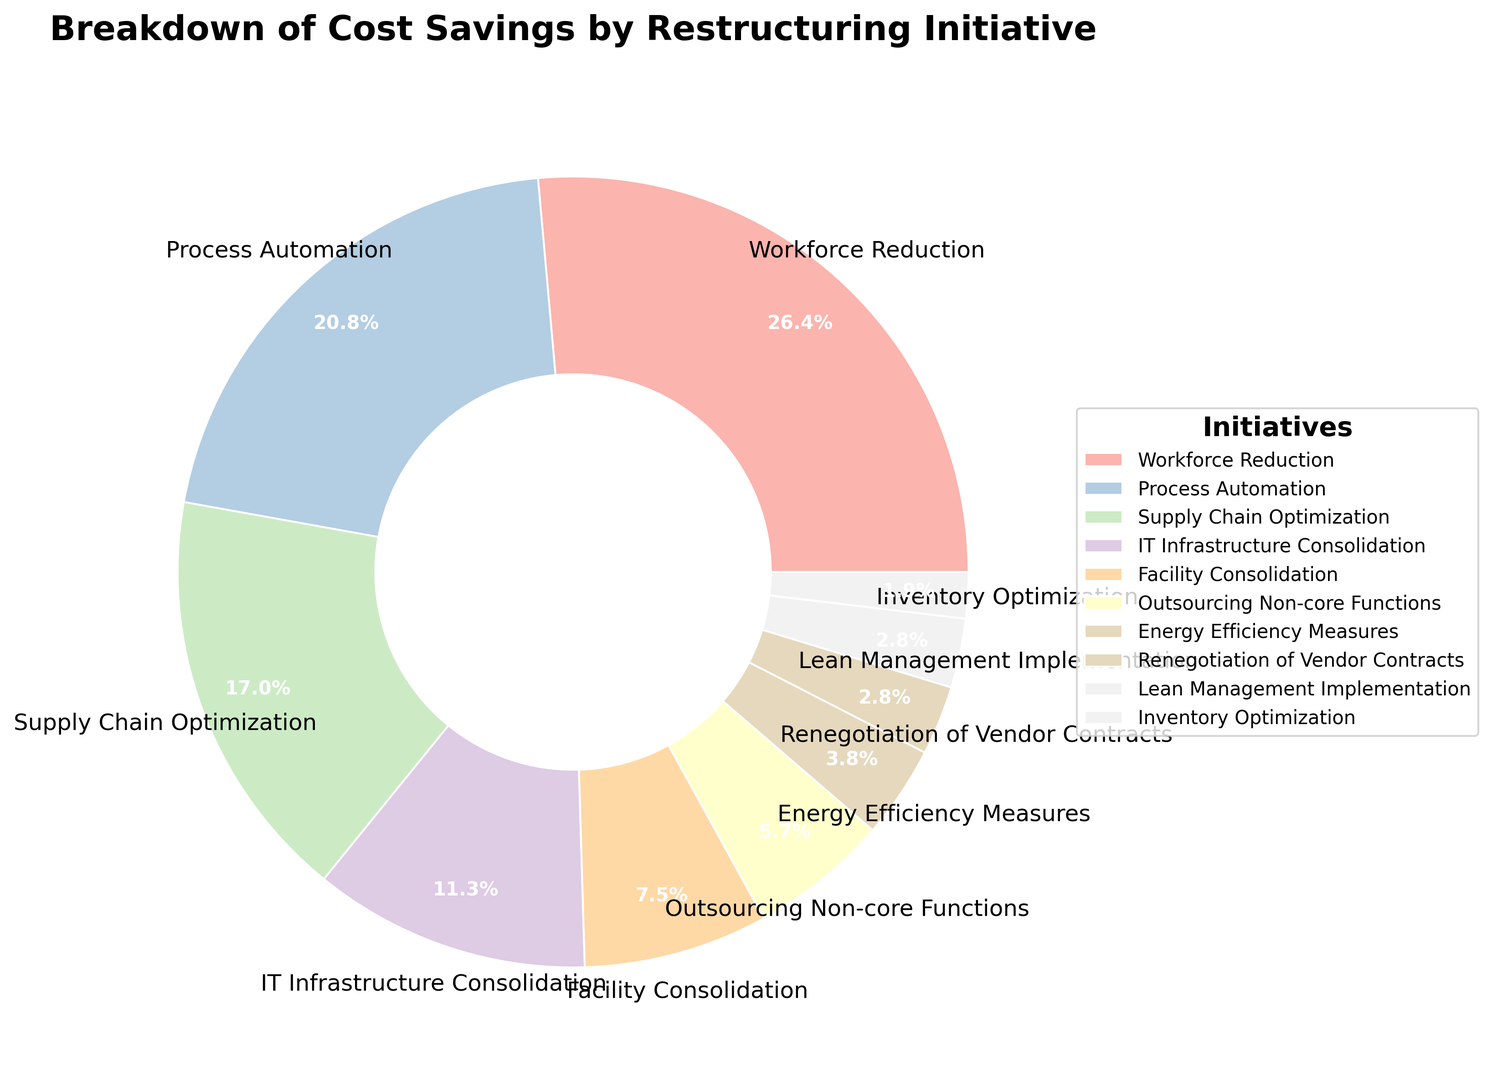What's the most significant cost-saving initiative represented in the chart? The initiative taking up the largest portion of the ring chart is 'Workforce Reduction', which is illustrated by a segment labeled with the highest percentage.
Answer: Workforce Reduction Which two initiatives together contribute to 40% of the cost savings? Initiatives 'Process Automation' and 'Supply Chain Optimization' together contribute 22% + 18% = 40%, as labeled on the chart.
Answer: Process Automation and Supply Chain Optimization Among 'Facility Consolidation', 'Energy Efficiency Measures', and 'Renegotiation of Vendor Contracts', which one contributes the least to cost savings? 'Renegotiation of Vendor Contracts' has the smallest segment among the three, making up only 3% of the ring chart.
Answer: Renegotiation of Vendor Contracts How much larger is the contribution of 'Workforce Reduction' compared to 'IT Infrastructure Consolidation'? The savings from 'Workforce Reduction' is 28%, and from 'IT Infrastructure Consolidation' is 12%. The difference is 28% - 12% = 16%.
Answer: 16% Which initiative represented in a pastel green color contributes to cost savings, and what is its percentage? On the color-coded ring chart, the initiative 'Supply Chain Optimization' is shown in a pastel green section, contributing 18% to the cost savings.
Answer: Supply Chain Optimization, 18% What is the total percentage of cost savings contributed by initiatives with less than 10% each? Adding the percentages of 'Outsourcing Non-core Functions' (6%), 'Energy Efficiency Measures' (4%), 'Renegotiation of Vendor Contracts' (3%), 'Lean Management Implementation' (3%), and 'Inventory Optimization' (2%) gives a total: 6% + 4% + 3% + 3% + 2% = 18%.
Answer: 18% Which initiatives have the exact same contribution percentage and what is that percentage? 'Renegotiation of Vendor Contracts' and 'Lean Management Implementation' both contribute 3% to the cost savings, as seen from identical-sized sections on the chart.
Answer: Renegotiation of Vendor Contracts and Lean Management Implementation, 3% What is the average percentage contribution of 'IT Infrastructure Consolidation', 'Facility Consolidation', and 'Outsourcing Non-core Functions'? Sum the contributions of 'IT Infrastructure Consolidation' (12%), 'Facility Consolidation' (8%), and 'Outsourcing Non-core Functions' (6%) which is 12% + 8% + 6% = 26%. The average is 26% / 3 = 8.67% ≈ 8.7%.
Answer: 8.7% Is the portion attributed to 'Lean Management Implementation' larger than 'Inventory Optimization'? 'Lean Management Implementation' is 3% and 'Inventory Optimization' is 2%, hence 'Lean Management Implementation' has a larger portion.
Answer: Yes How do 'Process Automation' and 'IT Infrastructure Consolidation' combined compare to 'Workforce Reduction' in terms of percentage? Adding 'Process Automation' (22%) and 'IT Infrastructure Consolidation' (12%) gives 22% + 12% = 34%, which is larger than 'Workforce Reduction' (28%).
Answer: Larger 